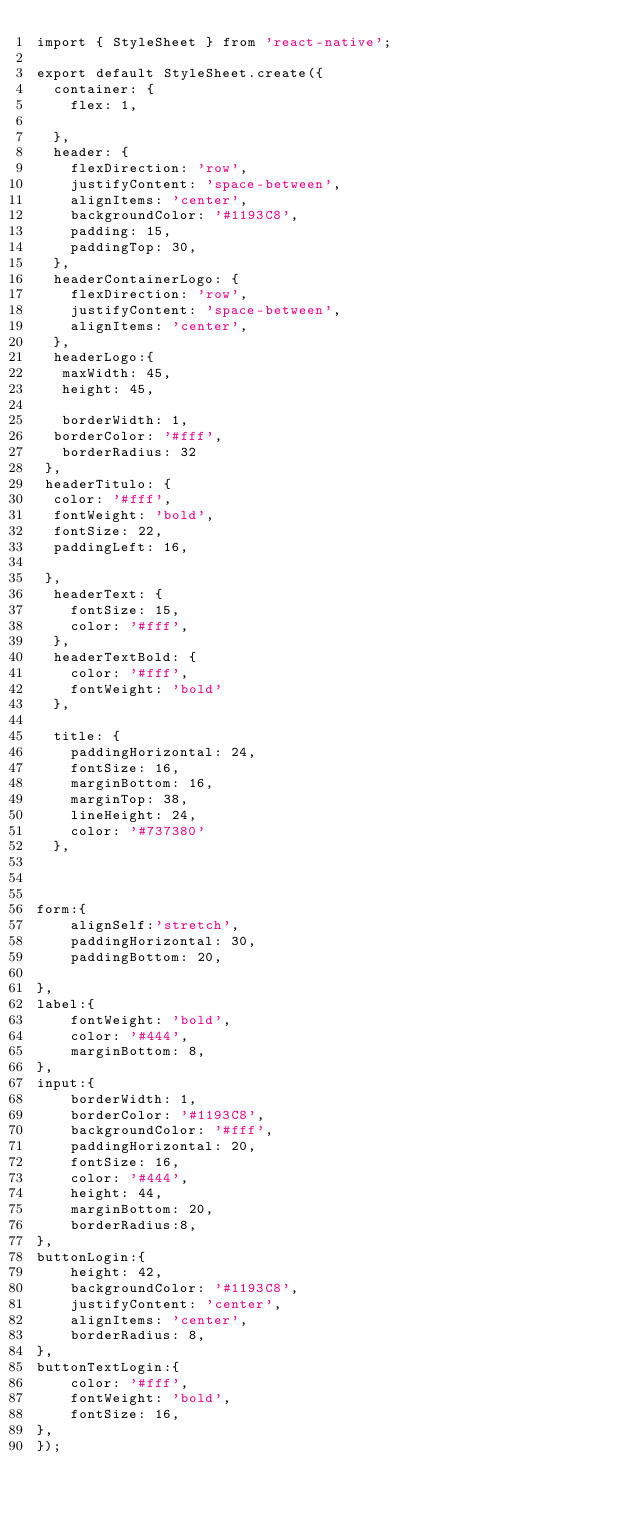Convert code to text. <code><loc_0><loc_0><loc_500><loc_500><_JavaScript_>import { StyleSheet } from 'react-native';

export default StyleSheet.create({
  container: {
    flex: 1,
     
  },
  header: {
    flexDirection: 'row',
    justifyContent: 'space-between',
    alignItems: 'center',
    backgroundColor: '#1193C8',
    padding: 15,
    paddingTop: 30,
  },
  headerContainerLogo: {
    flexDirection: 'row',
    justifyContent: 'space-between',
    alignItems: 'center',
  },
  headerLogo:{
   maxWidth: 45,
   height: 45,
   
   borderWidth: 1,
  borderColor: '#fff',
   borderRadius: 32
 },
 headerTitulo: {
  color: '#fff',
  fontWeight: 'bold',
  fontSize: 22,
  paddingLeft: 16,

 },
  headerText: {
    fontSize: 15,
    color: '#fff',
  },
  headerTextBold: {
    color: '#fff',
    fontWeight: 'bold'
  },
  
  title: {
    paddingHorizontal: 24,
    fontSize: 16,
    marginBottom: 16,
    marginTop: 38,
    lineHeight: 24,
    color: '#737380' 
  },
 
 

form:{
    alignSelf:'stretch',
    paddingHorizontal: 30,
    paddingBottom: 20,
    
},
label:{
    fontWeight: 'bold',
    color: '#444',
    marginBottom: 8,
},
input:{
    borderWidth: 1,
    borderColor: '#1193C8',
    backgroundColor: '#fff',
    paddingHorizontal: 20,
    fontSize: 16,
    color: '#444',
    height: 44,
    marginBottom: 20,
    borderRadius:8, 
},
buttonLogin:{
    height: 42,
    backgroundColor: '#1193C8',
    justifyContent: 'center',
    alignItems: 'center',
    borderRadius: 8,
},
buttonTextLogin:{
    color: '#fff',
    fontWeight: 'bold',
    fontSize: 16,
},
});</code> 